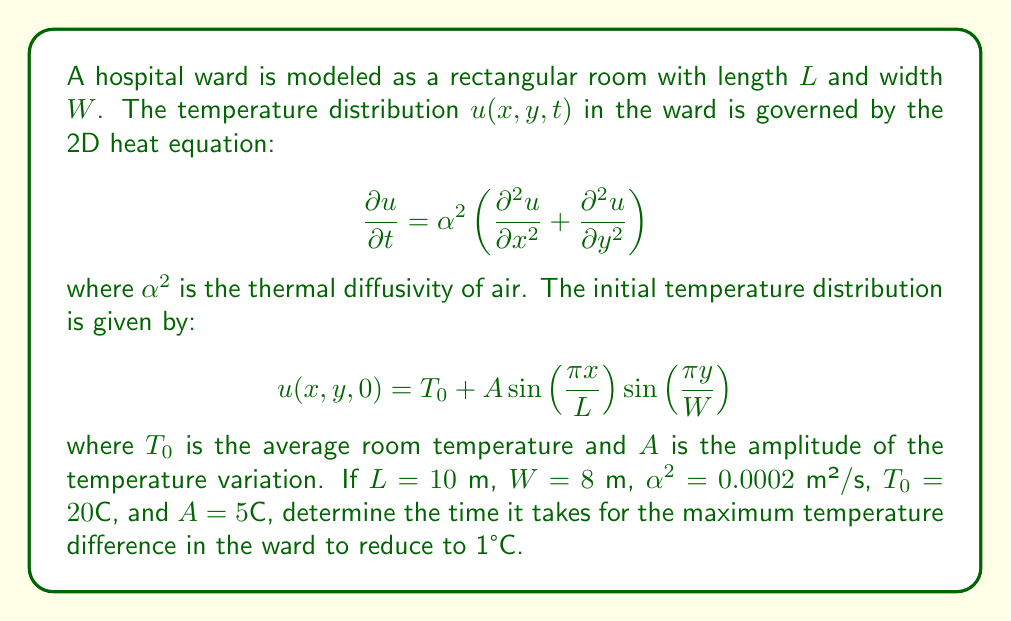Could you help me with this problem? To solve this problem, we need to follow these steps:

1) The general solution to the 2D heat equation with the given initial condition is:

   $$u(x,y,t) = T_0 + A e^{-\alpha^2 \pi^2 (\frac{1}{L^2} + \frac{1}{W^2})t} \sin\left(\frac{\pi x}{L}\right) \sin\left(\frac{\pi y}{W}\right)$$

2) The maximum temperature difference occurs between the center of the room and the corners. At time $t$, this difference is:

   $$\Delta T(t) = A e^{-\alpha^2 \pi^2 (\frac{1}{L^2} + \frac{1}{W^2})t}$$

3) We want to find $t$ when $\Delta T(t) = 1°C$. So we need to solve:

   $$1 = 5 e^{-0.0002 \pi^2 (\frac{1}{10^2} + \frac{1}{8^2})t}$$

4) Taking natural logarithm of both sides:

   $$\ln(0.2) = -0.0002 \pi^2 (\frac{1}{100} + \frac{1}{64})t$$

5) Solving for $t$:

   $$t = \frac{\ln(0.2)}{-0.0002 \pi^2 (\frac{1}{100} + \frac{1}{64})} \approx 3052.8$$

Therefore, it takes approximately 3053 seconds or about 51 minutes for the maximum temperature difference to reduce to 1°C.
Answer: 3053 seconds 